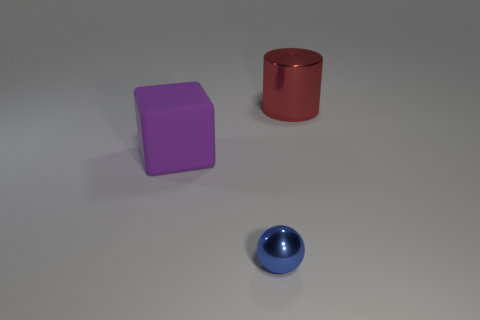Do the red shiny object and the shiny object in front of the big block have the same size?
Provide a succinct answer. No. Are there any red metallic things that have the same size as the blue metallic object?
Provide a short and direct response. No. How many other objects are there of the same material as the large purple block?
Ensure brevity in your answer.  0. The thing that is behind the small object and on the right side of the rubber cube is what color?
Give a very brief answer. Red. Do the big thing that is on the right side of the matte thing and the thing that is in front of the purple block have the same material?
Offer a very short reply. Yes. Does the shiny thing that is behind the blue metal ball have the same size as the purple block?
Make the answer very short. Yes. There is a large purple object; what shape is it?
Provide a succinct answer. Cube. How many objects are shiny things to the left of the big metallic cylinder or tiny blue metal objects?
Give a very brief answer. 1. What size is the cylinder that is made of the same material as the tiny blue object?
Ensure brevity in your answer.  Large. Are there more large red shiny cylinders that are right of the large purple matte cube than gray blocks?
Make the answer very short. Yes. 